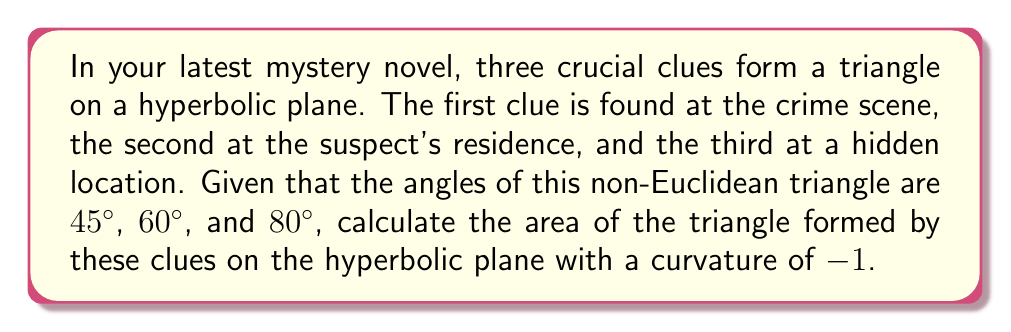Give your solution to this math problem. To solve this problem, we'll use the Gauss-Bonnet formula for hyperbolic triangles:

$$A = \pi - (\alpha + \beta + \gamma)$$

Where $A$ is the area of the hyperbolic triangle, and $\alpha$, $\beta$, and $\gamma$ are the angles of the triangle in radians.

Step 1: Convert the given angles from degrees to radians:
$45° = \frac{\pi}{4}$ rad
$60° = \frac{\pi}{3}$ rad
$80° = \frac{4\pi}{9}$ rad

Step 2: Sum the angles:
$$\alpha + \beta + \gamma = \frac{\pi}{4} + \frac{\pi}{3} + \frac{4\pi}{9} = \frac{9\pi}{36} + \frac{12\pi}{36} + \frac{16\pi}{36} = \frac{37\pi}{36}$$

Step 3: Apply the Gauss-Bonnet formula:
$$A = \pi - \frac{37\pi}{36} = \frac{36\pi}{36} - \frac{37\pi}{36} = -\frac{\pi}{36}$$

Step 4: The area is negative, which is expected in hyperbolic geometry. To get the absolute value:
$$|A| = \frac{\pi}{36}$$

Note: In hyperbolic geometry with curvature -1, the area is measured in the same units as squared length.
Answer: $\frac{\pi}{36}$ 